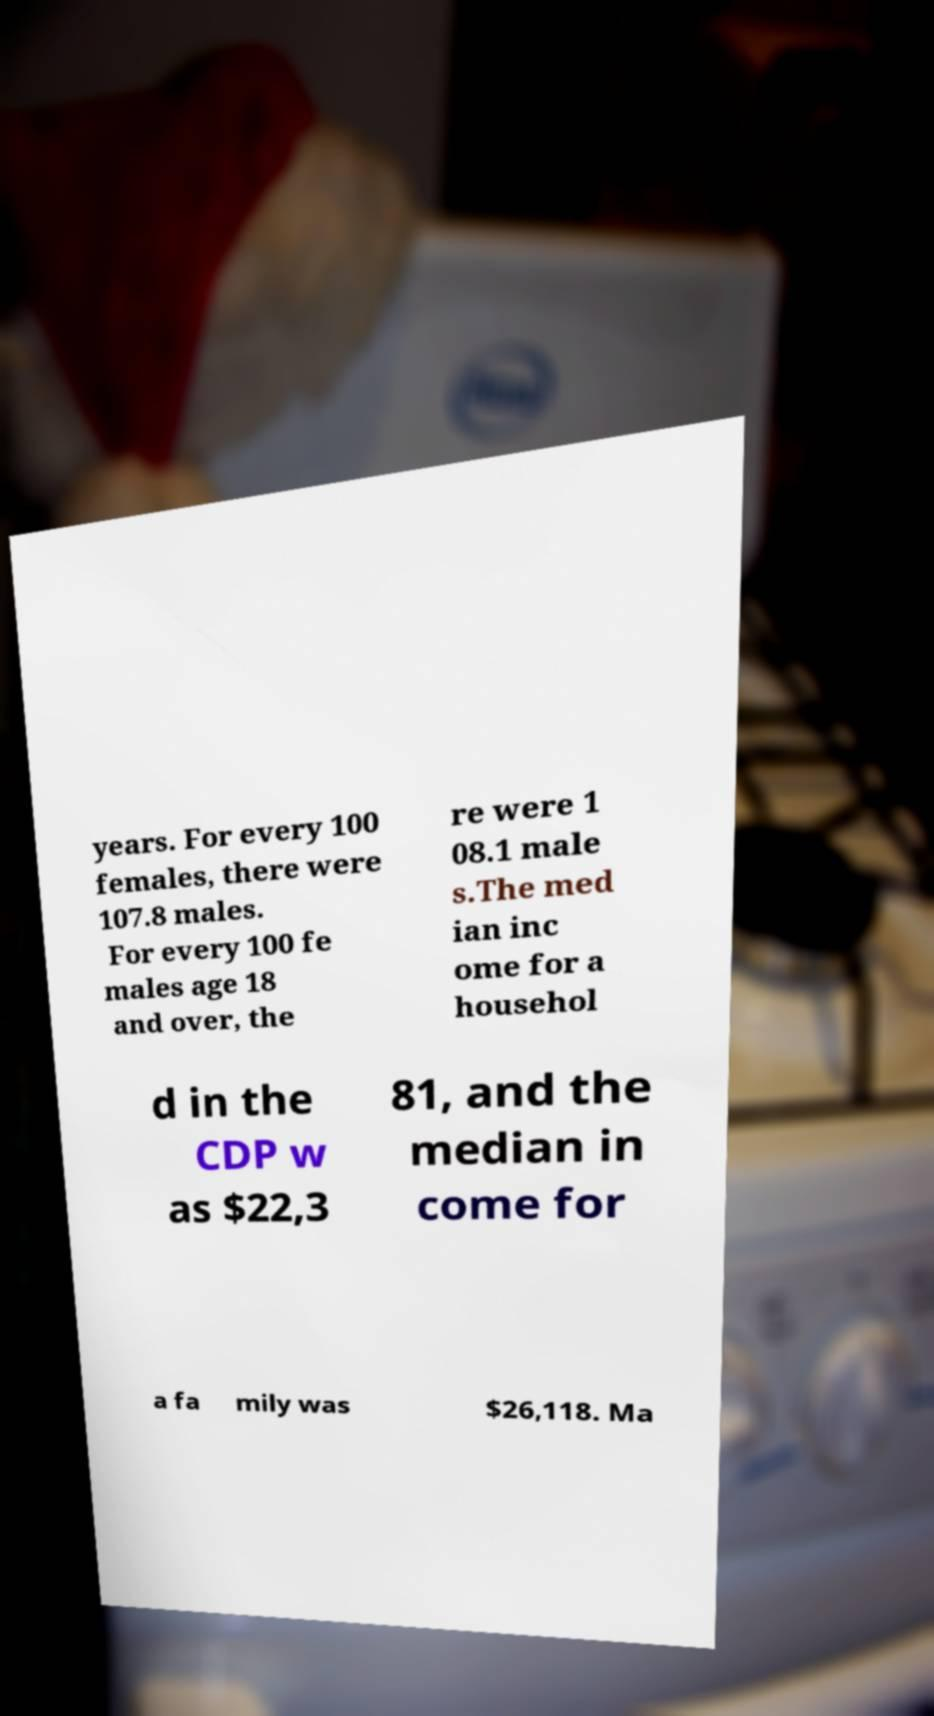Can you read and provide the text displayed in the image?This photo seems to have some interesting text. Can you extract and type it out for me? years. For every 100 females, there were 107.8 males. For every 100 fe males age 18 and over, the re were 1 08.1 male s.The med ian inc ome for a househol d in the CDP w as $22,3 81, and the median in come for a fa mily was $26,118. Ma 